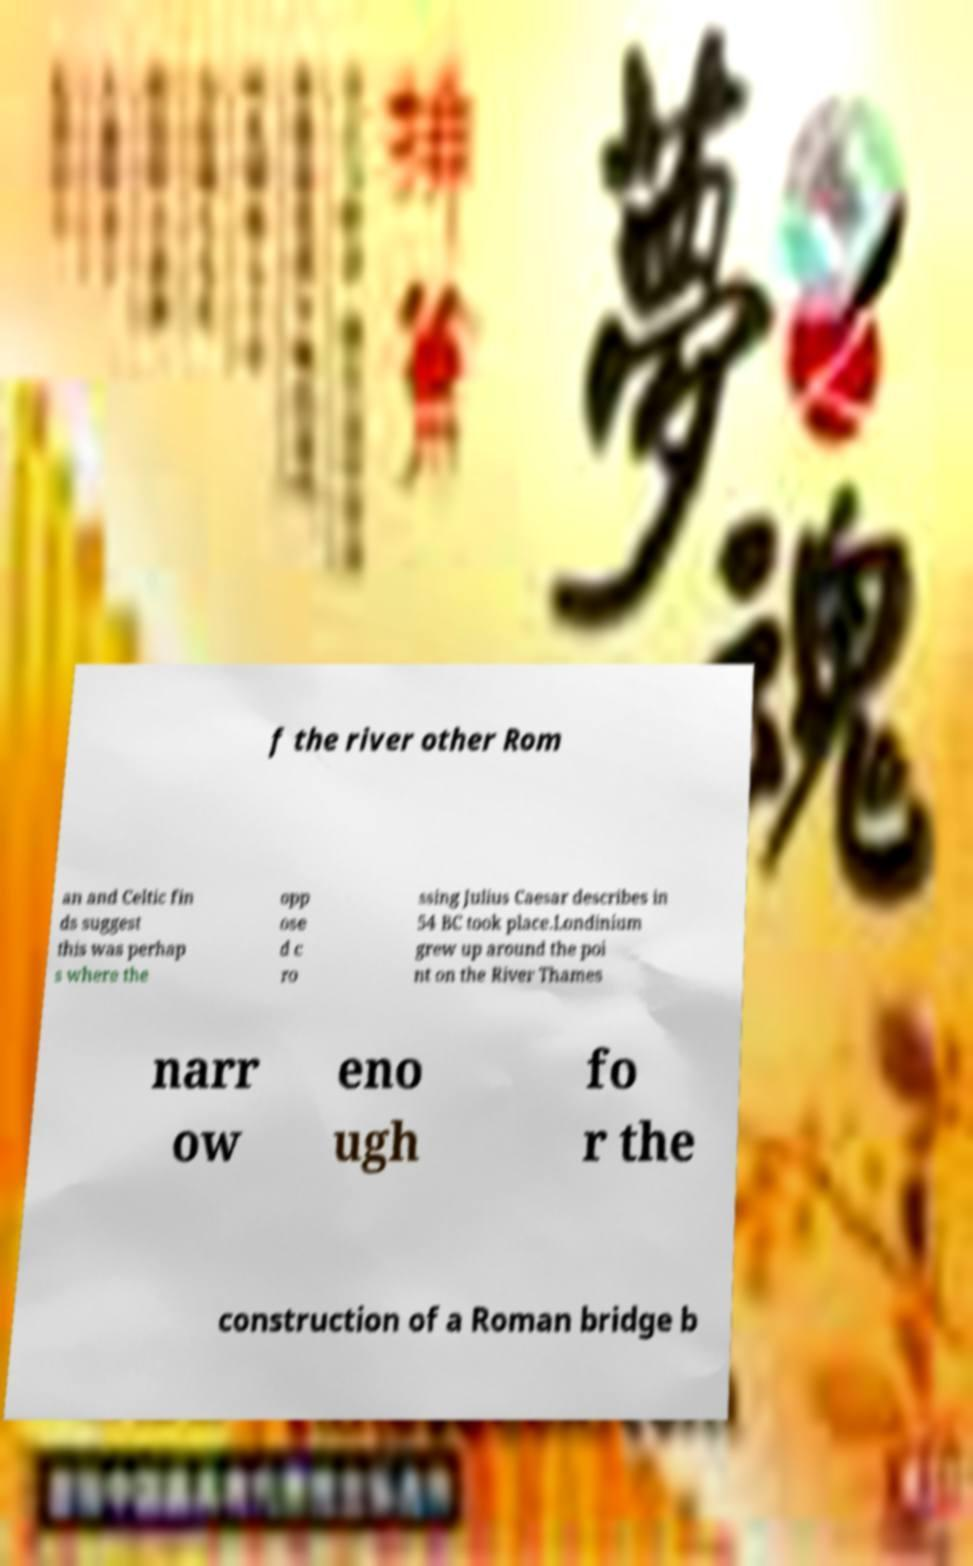Please read and relay the text visible in this image. What does it say? f the river other Rom an and Celtic fin ds suggest this was perhap s where the opp ose d c ro ssing Julius Caesar describes in 54 BC took place.Londinium grew up around the poi nt on the River Thames narr ow eno ugh fo r the construction of a Roman bridge b 